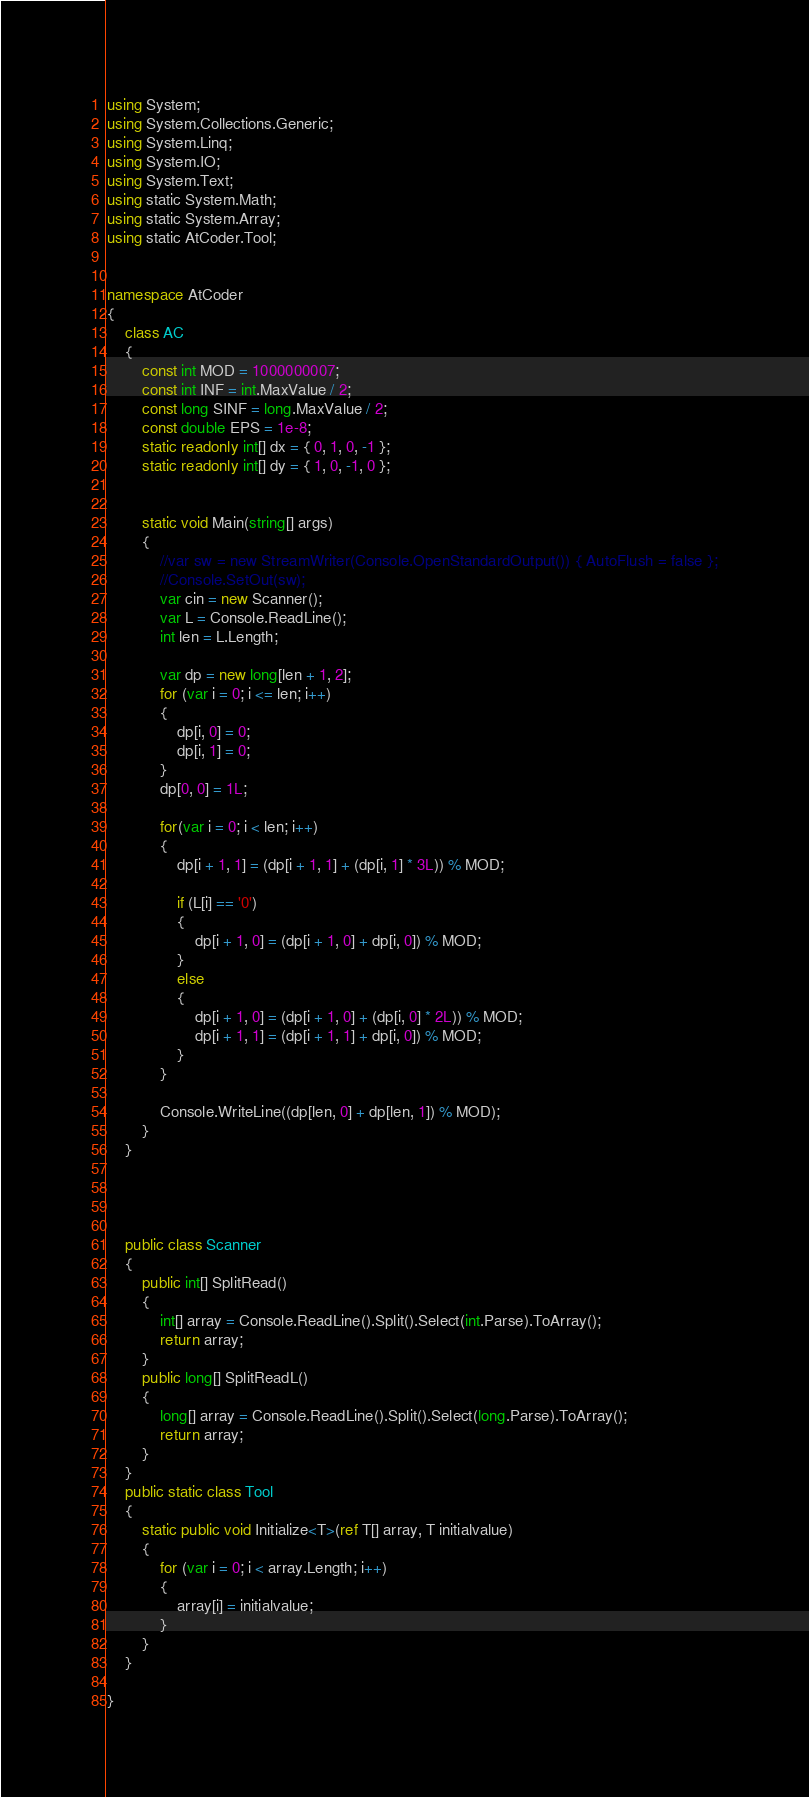<code> <loc_0><loc_0><loc_500><loc_500><_C#_>using System;
using System.Collections.Generic;
using System.Linq;
using System.IO;
using System.Text;
using static System.Math;
using static System.Array;
using static AtCoder.Tool;


namespace AtCoder
{
    class AC
    {
        const int MOD = 1000000007;
        const int INF = int.MaxValue / 2;
        const long SINF = long.MaxValue / 2;
        const double EPS = 1e-8;
        static readonly int[] dx = { 0, 1, 0, -1 };
        static readonly int[] dy = { 1, 0, -1, 0 };
        

        static void Main(string[] args)
        {
            //var sw = new StreamWriter(Console.OpenStandardOutput()) { AutoFlush = false };
            //Console.SetOut(sw);
            var cin = new Scanner();
            var L = Console.ReadLine();
            int len = L.Length;

            var dp = new long[len + 1, 2];
            for (var i = 0; i <= len; i++) 
            {
                dp[i, 0] = 0;
                dp[i, 1] = 0;
            }
            dp[0, 0] = 1L;

            for(var i = 0; i < len; i++)
            {
                dp[i + 1, 1] = (dp[i + 1, 1] + (dp[i, 1] * 3L)) % MOD;

                if (L[i] == '0')
                {
                    dp[i + 1, 0] = (dp[i + 1, 0] + dp[i, 0]) % MOD;
                }
                else
                {
                    dp[i + 1, 0] = (dp[i + 1, 0] + (dp[i, 0] * 2L)) % MOD;
                    dp[i + 1, 1] = (dp[i + 1, 1] + dp[i, 0]) % MOD;
                }
            }

            Console.WriteLine((dp[len, 0] + dp[len, 1]) % MOD);
        }
    }

   


    public class Scanner
    {
        public int[] SplitRead()
        {
            int[] array = Console.ReadLine().Split().Select(int.Parse).ToArray();
            return array;
        }
        public long[] SplitReadL()
        {
            long[] array = Console.ReadLine().Split().Select(long.Parse).ToArray();
            return array;
        }
    }
    public static class Tool
    {
        static public void Initialize<T>(ref T[] array, T initialvalue)
        {
            for (var i = 0; i < array.Length; i++)
            {
                array[i] = initialvalue;
            }
        }
    }

}
</code> 